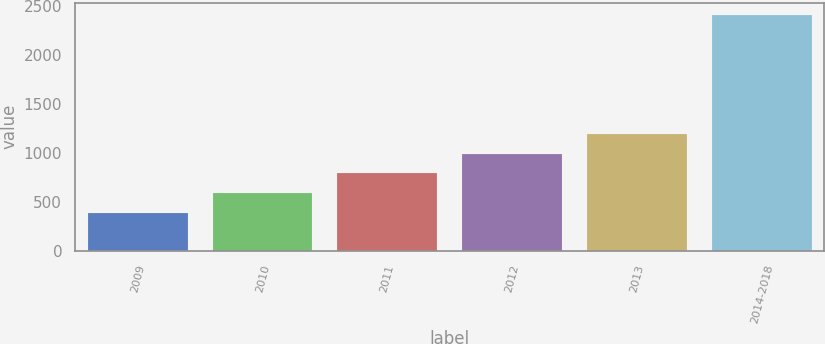Convert chart. <chart><loc_0><loc_0><loc_500><loc_500><bar_chart><fcel>2009<fcel>2010<fcel>2011<fcel>2012<fcel>2013<fcel>2014-2018<nl><fcel>384<fcel>587.2<fcel>790.4<fcel>993.6<fcel>1196.8<fcel>2416<nl></chart> 